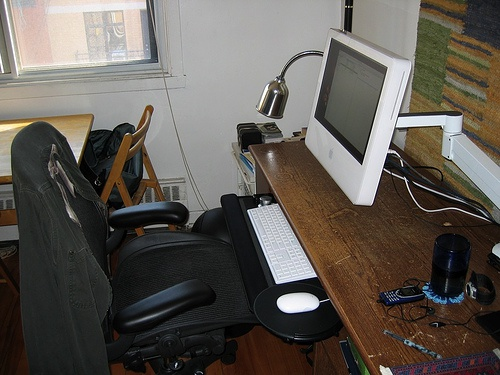Describe the objects in this image and their specific colors. I can see chair in gray, black, darkblue, and maroon tones, tv in gray, lightgray, darkgray, and black tones, chair in gray, black, maroon, and darkgray tones, keyboard in gray, lightgray, and darkgray tones, and cup in gray, black, and blue tones in this image. 